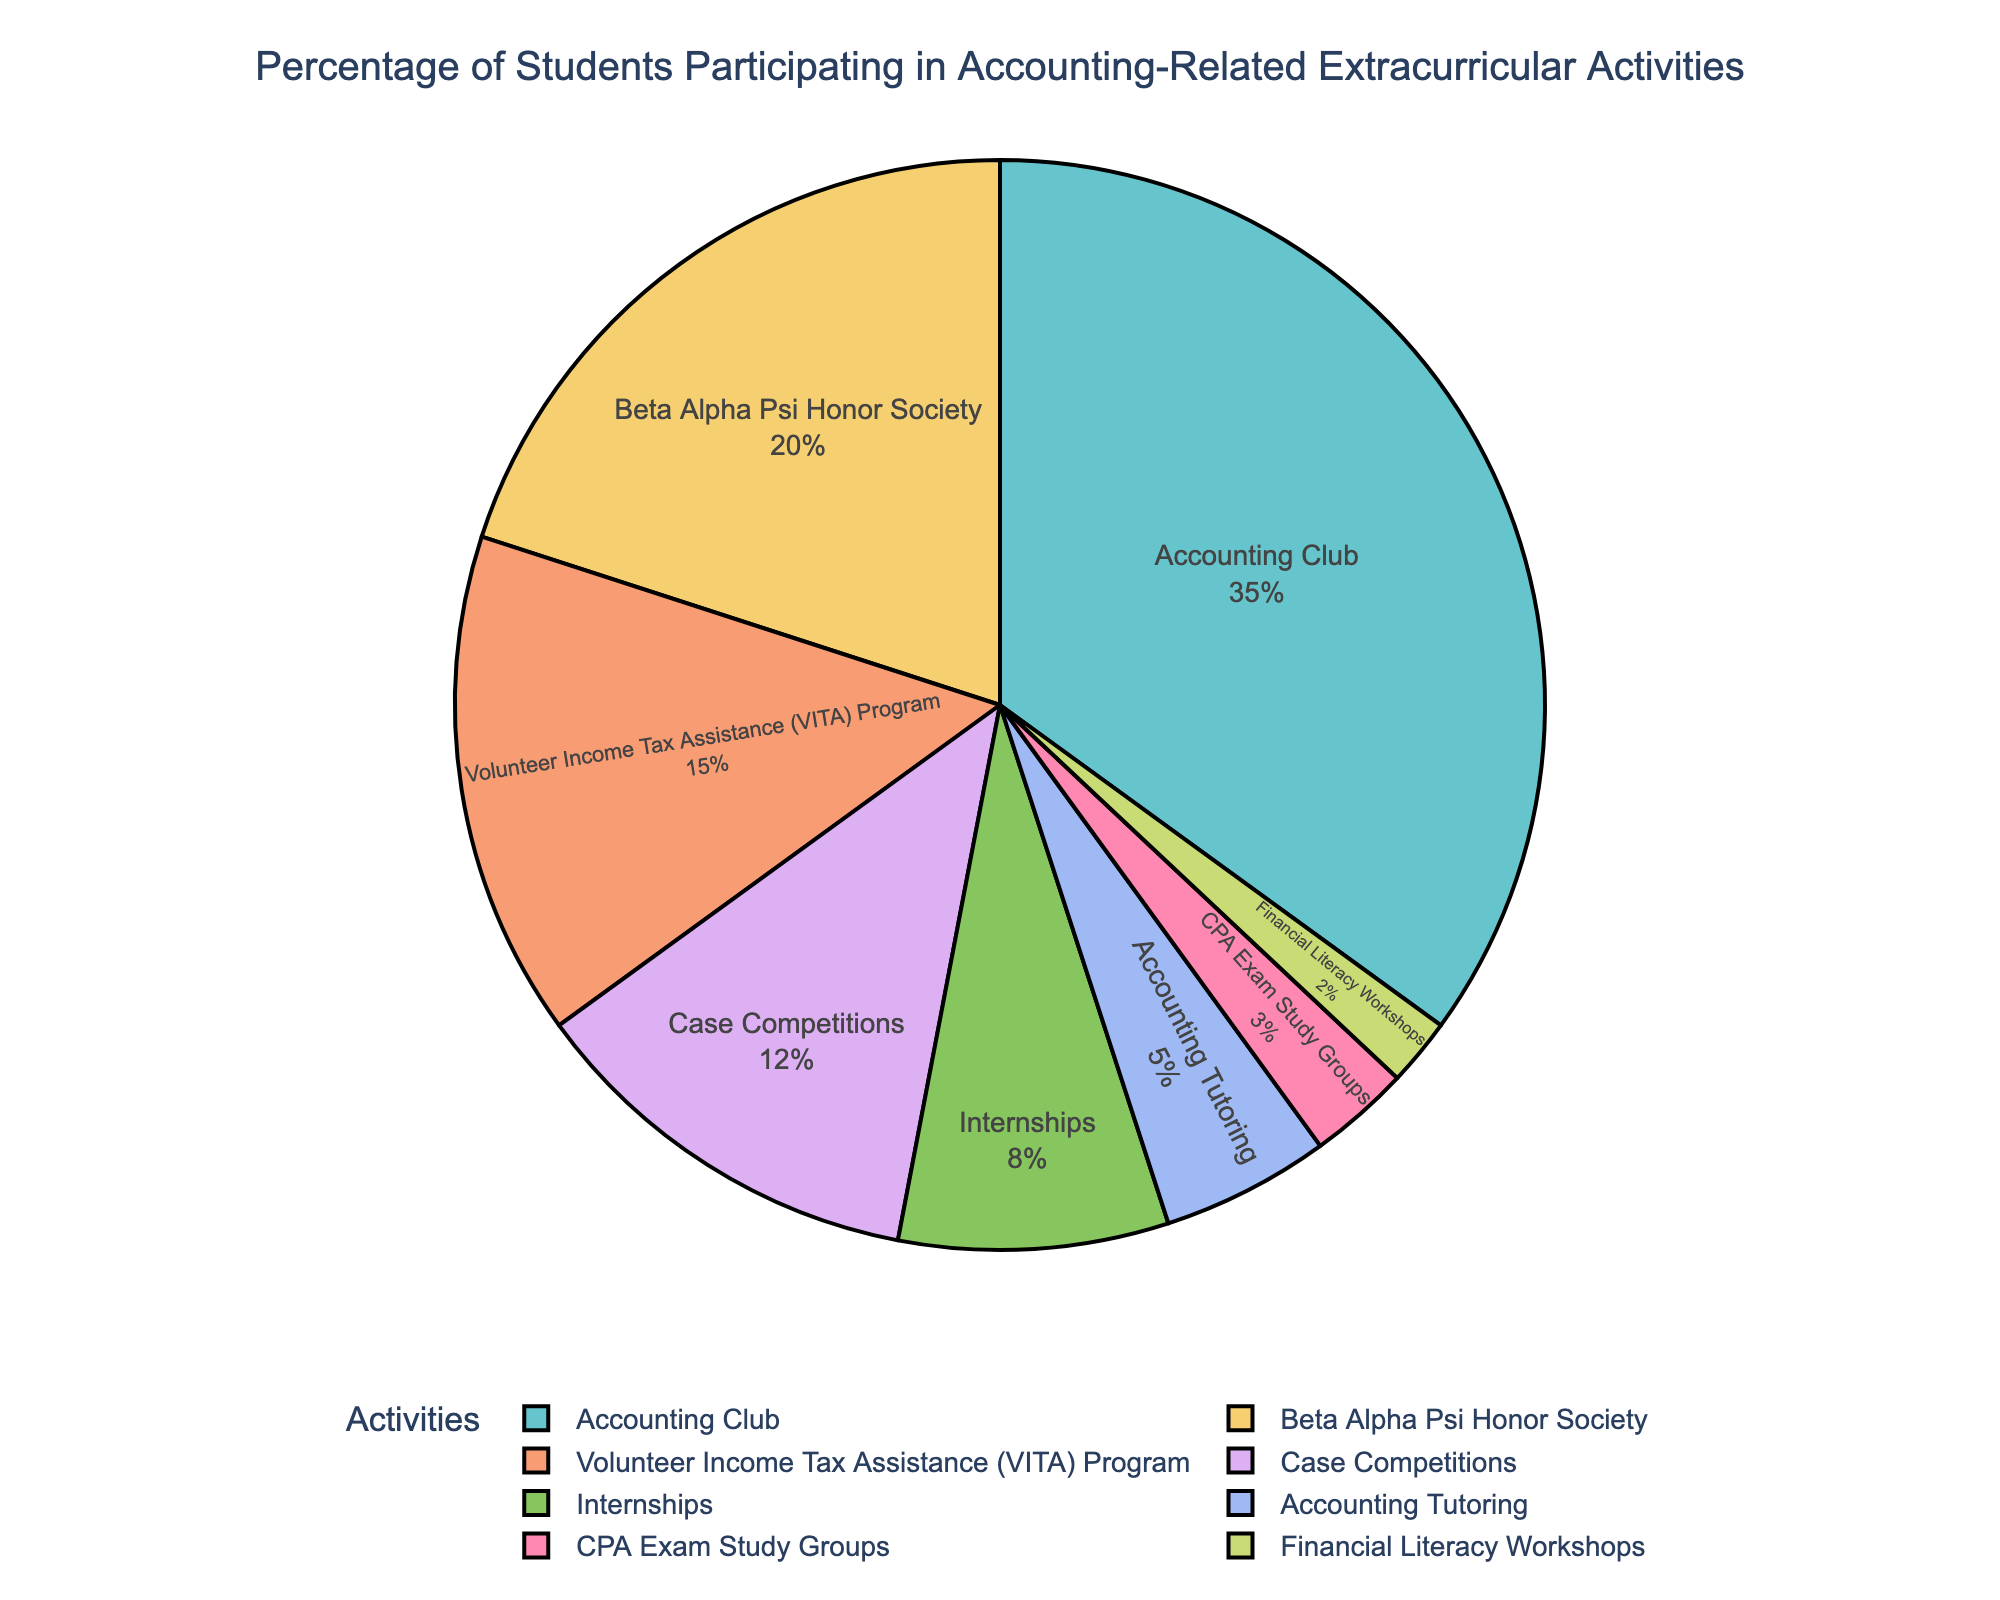What's the most popular extracurricular activity? The segment labeled "Accounting Club" occupies the largest portion of the pie chart.
Answer: Accounting Club How much more popular is the Accounting Club compared to Beta Alpha Psi Honor Society? Subtract the percentage of students in Beta Alpha Psi Honor Society (20%) from those in Accounting Club (35%). 35% - 20% = 15%
Answer: 15% Which activity has the least participation and what is its percentage? The smallest segment in the pie chart is labeled "Financial Literacy Workshops," which has a percentage of 2%.
Answer: Financial Literacy Workshops, 2% If you combine the participation of Case Competitions and Internships, what percentage do you get? Add the percentages of Case Competitions (12%) and Internships (8%). 12% + 8% = 20%
Answer: 20% How does the participation in Accounting Tutoring compare to CPA Exam Study Groups? The slice labeled "Accounting Tutoring" is larger than the slice labeled "CPA Exam Study Groups." Accounting Tutoring has 5%, while CPA Exam Study Groups have 3%.
Answer: Accounting Tutoring has a higher percentage than CPA Exam Study Groups What's the total percentage of students involved in Internships, Accounting Tutoring, and CPA Exam Study Groups? Sum the percentages for Internships (8%), Accounting Tutoring (5%), and CPA Exam Study Groups (3%). 8% + 5% + 3% = 16%
Answer: 16% Which activities have a participation rate above 10%? The slices representing "Accounting Club" (35%), "Beta Alpha Psi Honor Society" (20%), and "Case Competitions" (12%) have percentages greater than 10%.
Answer: Accounting Club, Beta Alpha Psi Honor Society, Case Competitions Are there more students participating in the Volunteer Income Tax Assistance (VITA) Program or Financial Literacy Workshops and CPA Exam Study Groups combined? Compare VITA's percentage (15%) to the combined percentage of Financial Literacy Workshops (2%) and CPA Exam Study Groups (3%). 2% + 3% = 5%; 15% > 5%
Answer: VITA Program has more participants 